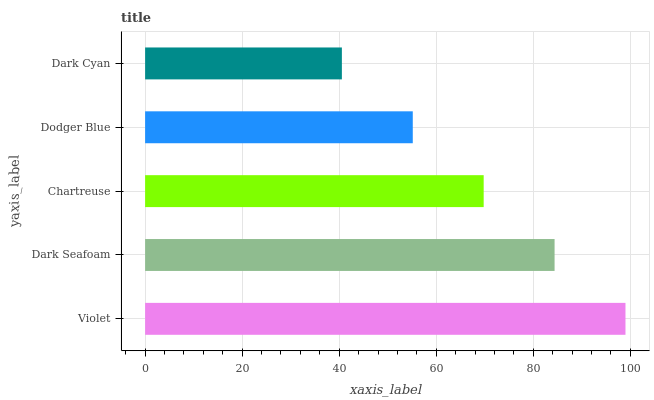Is Dark Cyan the minimum?
Answer yes or no. Yes. Is Violet the maximum?
Answer yes or no. Yes. Is Dark Seafoam the minimum?
Answer yes or no. No. Is Dark Seafoam the maximum?
Answer yes or no. No. Is Violet greater than Dark Seafoam?
Answer yes or no. Yes. Is Dark Seafoam less than Violet?
Answer yes or no. Yes. Is Dark Seafoam greater than Violet?
Answer yes or no. No. Is Violet less than Dark Seafoam?
Answer yes or no. No. Is Chartreuse the high median?
Answer yes or no. Yes. Is Chartreuse the low median?
Answer yes or no. Yes. Is Violet the high median?
Answer yes or no. No. Is Violet the low median?
Answer yes or no. No. 